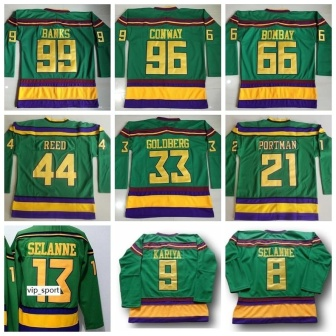How could these jerseys be used to create an engaging exhibit at a sports museum? Creating an engaging exhibit at a sports museum with these jerseys involves several creative strategies. Display them in a well-lit, prominent section where visitors can view each jersey clearly. Accompanying the jerseys could be interactive touchscreens that provide information about the players, including their careers, key moments, and personal anecdotes. Each screen could feature video highlights, interviews, and historical game footage, bringing the stories behind the jerseys to life. Additionally, including augmented reality experiences where visitors can visualize themselves wearing the jerseys and participating in iconic game moments could make the exhibit exceedingly immersive. Integrating sensory elements like the sounds of a roaring crowd or the commentary of memorable games would create a holistic and captivating experience for visitors. Imagine these jerseys as part of a fictional alternate universe where hockey is played not on ice, but on giant lily pads floating in enchanted waters. What are the unique challenges the players face? In this imaginative alternate universe where hockey is played on giant lily pads floating in enchanted waters, players face a myriad of unique challenges. Firstly, stability is a major concern, as the lily pads, while large, sway and bob with every movement, requiring players to have exceptional balance and agility. The enchanted waters are filled with magical creatures that occasionally surface, adding unexpected obstacles and requiring players to adapt quickly. The rules of the game are altered; for instance, instead of ice skates, players wear special shoes with gripping treads to navigate the slippery surfaces. The enchanted environment also means that weather conditions are unpredictable—one moment, it could be a serene, misty morning; the next, a sudden gust of enchanted wind could create waves, making it harder to control the puck. These mesmerizing yet challenging conditions push players to be innovative in their strategies, making each game an exciting and captivating spectacle for audiences.  Could you detail a scenario where one of these jerseys was part of a memorable game? One memorable scenario involving the jersey marked 'Goldberg' with the number 33 took place during a crucial playoff game. The match was fiercely contested, with both teams tied in the final period. As the clock ticked down, tension in the arena was palpable. With only seconds remaining, 'Goldberg' found himself in a breakaway situation, thanks to a quick pass from his teammate. Racing towards the goal, he deftly maneuvered around the last defender, taking a wide-angle shot that seemed almost impossible. The puck soared past the goalie, hitting the top corner of the net, securing a dramatic victory. The crowd erupted in cheers, and 'Goldberg' was hoisted onto his teammates' shoulders in celebration. This game, and the jersey Goldberg wore, became legendary, representing a moment of sheer determination and skill that turned the tides in their favor, etching it forever in the annals of the team's history.  Please describe a short, special moment related to the player wearing the 'Conway' jersey. A special moment related to the player wearing the 'Conway' jersey, marked with the number 96, took place during a pivotal game in the regular season. With the score tied and only a few minutes left in the game, 'Conway' demonstrated exceptional leadership and composure. After winning a critical face-off in the offensive zone, he orchestrated a perfect play, making a swift pass to his winger, who managed to return the puck to Conway in a split-second window. Conway then executed a flawless one-timer, sending the puck straight into the net. This goal not only secured the win for his team but also exemplified his strategic brilliance and ability to perform under pressure. The crowd's chants of 'Conway, Conway' echoed through the arena, marking the moment as a highlight of his career and a testament to his contribution to the team's success. 